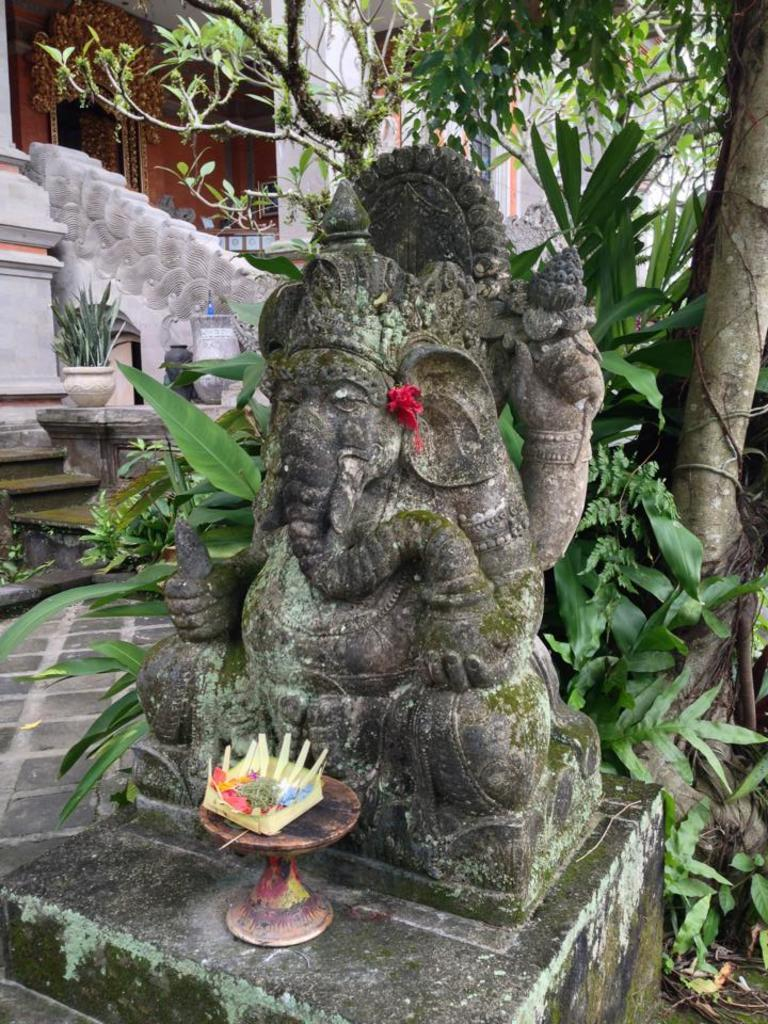What is the main subject of the image? There is a statue of a god in the image. What is located in front of the statue? There is an object on a stand in front of the statue. What can be seen in the background of the image? There are trees, a flower pot, and a building in the background of the image. Can you tell me how many people are involved in the fight depicted in the image? There is no fight depicted in the image; it features a statue of a god with an object on a stand in front of it, and various elements in the background. What type of calculator is being used by the god in the image? There is no calculator present in the image. 